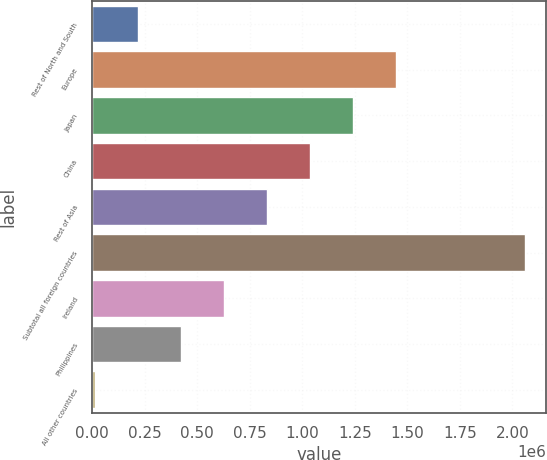Convert chart to OTSL. <chart><loc_0><loc_0><loc_500><loc_500><bar_chart><fcel>Rest of North and South<fcel>Europe<fcel>Japan<fcel>China<fcel>Rest of Asia<fcel>Subtotal all foreign countries<fcel>Ireland<fcel>Philippines<fcel>All other countries<nl><fcel>217316<fcel>1.44493e+06<fcel>1.24033e+06<fcel>1.03572e+06<fcel>831122<fcel>2.05873e+06<fcel>626520<fcel>421918<fcel>12714<nl></chart> 